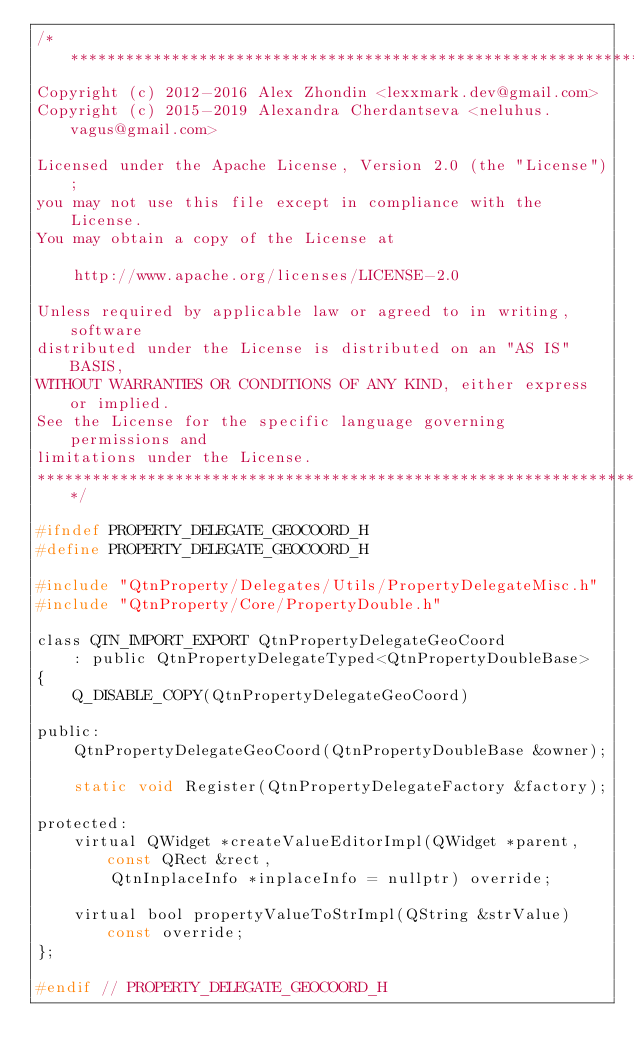Convert code to text. <code><loc_0><loc_0><loc_500><loc_500><_C_>/*******************************************************************************
Copyright (c) 2012-2016 Alex Zhondin <lexxmark.dev@gmail.com>
Copyright (c) 2015-2019 Alexandra Cherdantseva <neluhus.vagus@gmail.com>

Licensed under the Apache License, Version 2.0 (the "License");
you may not use this file except in compliance with the License.
You may obtain a copy of the License at

	http://www.apache.org/licenses/LICENSE-2.0

Unless required by applicable law or agreed to in writing, software
distributed under the License is distributed on an "AS IS" BASIS,
WITHOUT WARRANTIES OR CONDITIONS OF ANY KIND, either express or implied.
See the License for the specific language governing permissions and
limitations under the License.
*******************************************************************************/

#ifndef PROPERTY_DELEGATE_GEOCOORD_H
#define PROPERTY_DELEGATE_GEOCOORD_H

#include "QtnProperty/Delegates/Utils/PropertyDelegateMisc.h"
#include "QtnProperty/Core/PropertyDouble.h"

class QTN_IMPORT_EXPORT QtnPropertyDelegateGeoCoord
	: public QtnPropertyDelegateTyped<QtnPropertyDoubleBase>
{
	Q_DISABLE_COPY(QtnPropertyDelegateGeoCoord)

public:
	QtnPropertyDelegateGeoCoord(QtnPropertyDoubleBase &owner);

	static void Register(QtnPropertyDelegateFactory &factory);

protected:
	virtual QWidget *createValueEditorImpl(QWidget *parent, const QRect &rect,
		QtnInplaceInfo *inplaceInfo = nullptr) override;

	virtual bool propertyValueToStrImpl(QString &strValue) const override;
};

#endif // PROPERTY_DELEGATE_GEOCOORD_H
</code> 